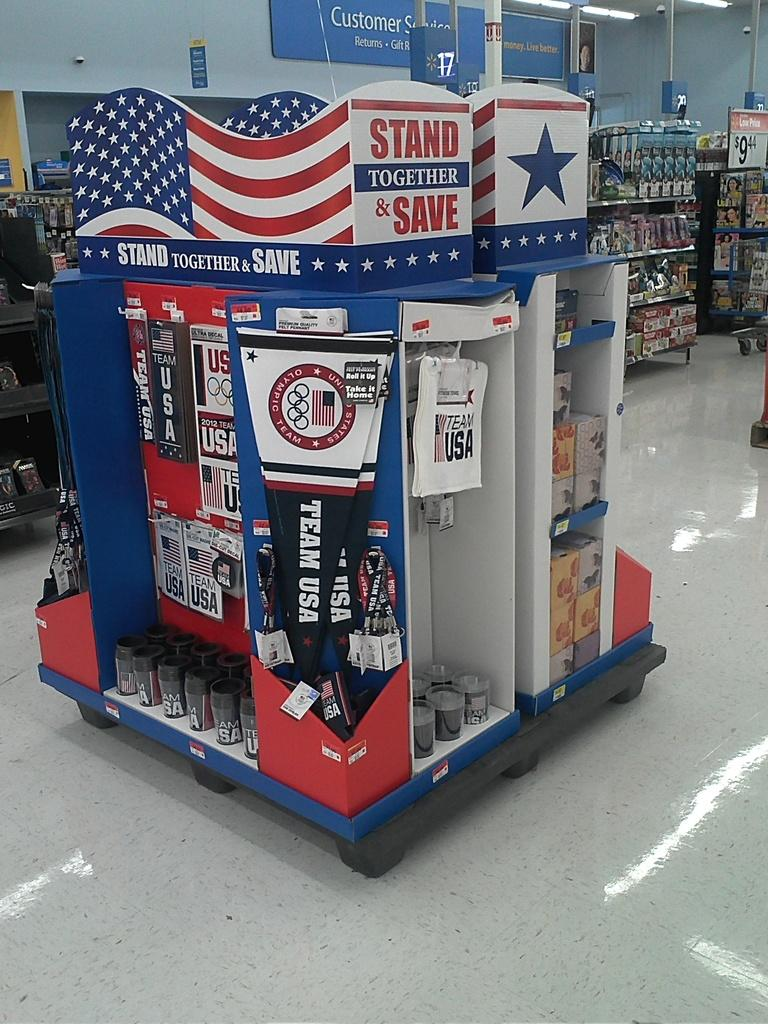<image>
Relay a brief, clear account of the picture shown. A sign that says to stand together and save is on top of a display in a store. 